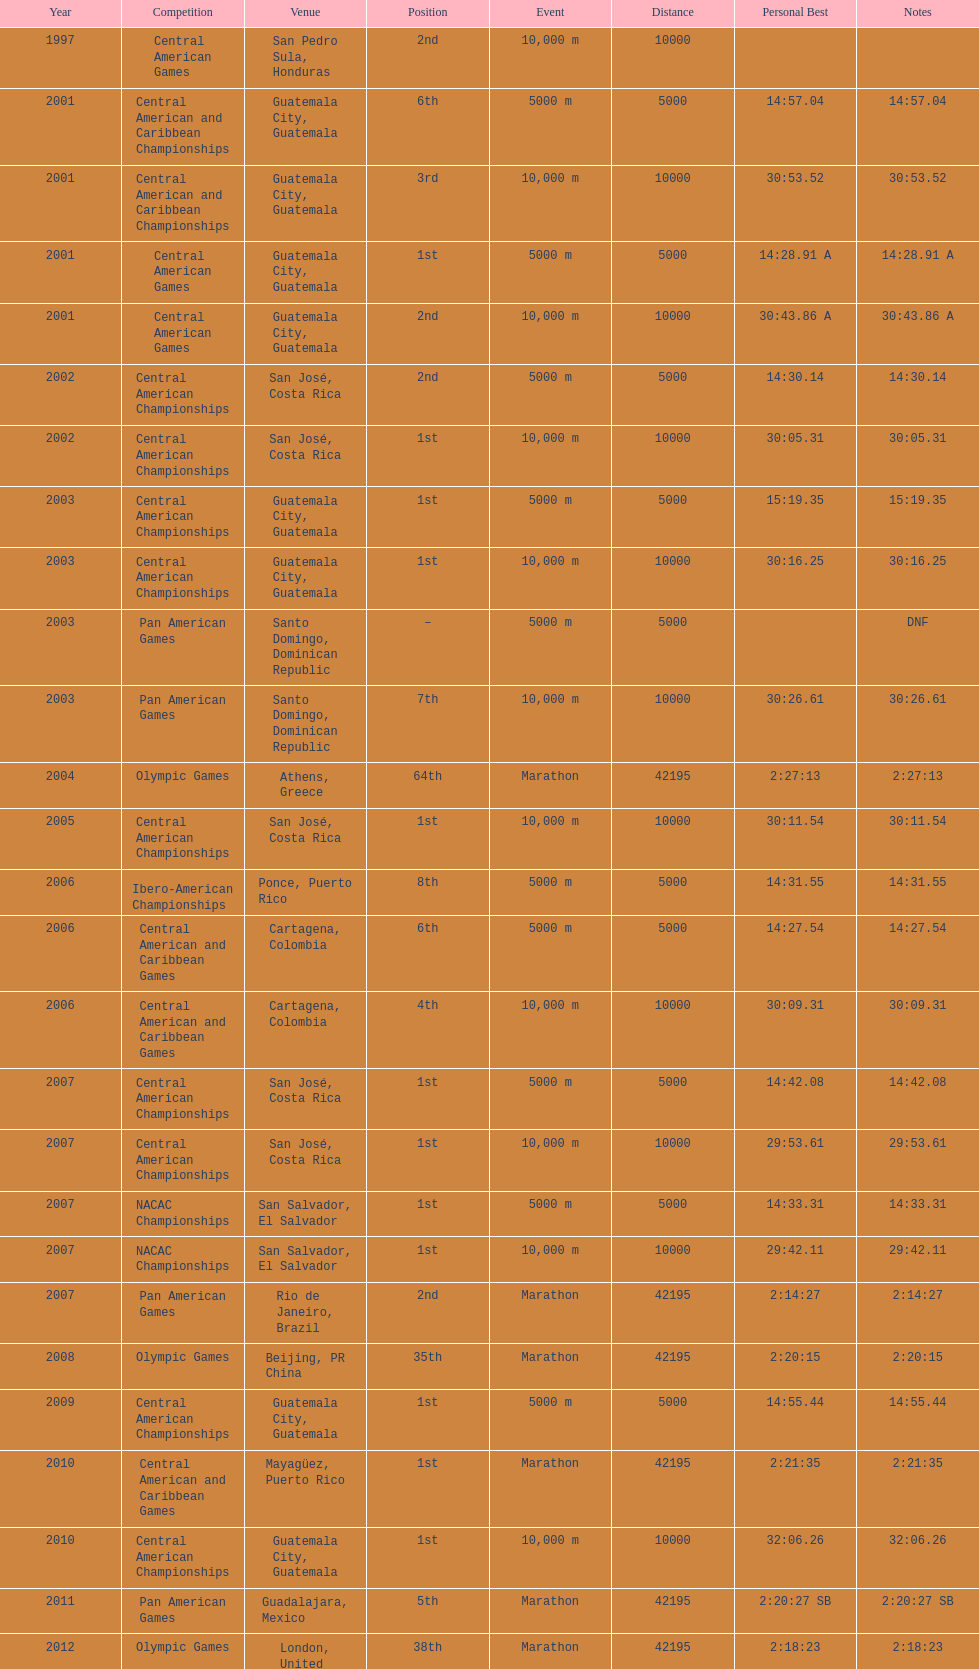How many times has this athlete not finished in a competition? 1. 